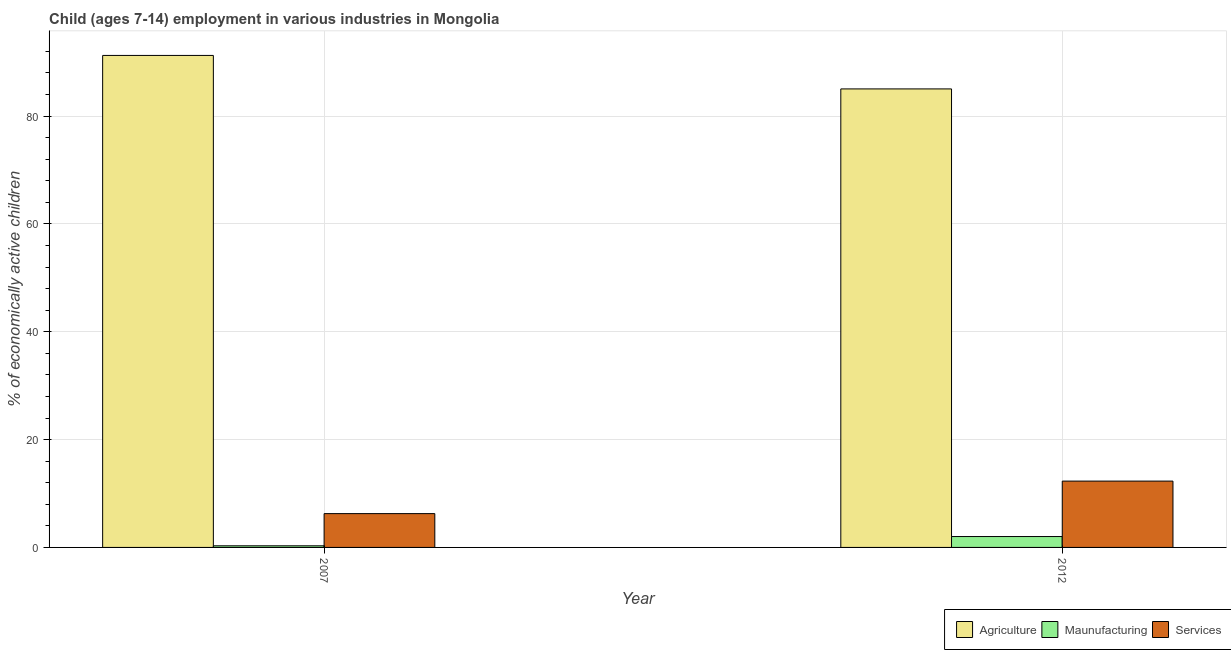How many different coloured bars are there?
Give a very brief answer. 3. Are the number of bars per tick equal to the number of legend labels?
Your answer should be compact. Yes. How many bars are there on the 1st tick from the left?
Provide a succinct answer. 3. How many bars are there on the 2nd tick from the right?
Offer a very short reply. 3. Across all years, what is the maximum percentage of economically active children in agriculture?
Keep it short and to the point. 91.25. Across all years, what is the minimum percentage of economically active children in agriculture?
Your answer should be very brief. 85.04. In which year was the percentage of economically active children in services maximum?
Keep it short and to the point. 2012. What is the total percentage of economically active children in agriculture in the graph?
Offer a terse response. 176.29. What is the difference between the percentage of economically active children in agriculture in 2007 and that in 2012?
Provide a short and direct response. 6.21. What is the difference between the percentage of economically active children in services in 2007 and the percentage of economically active children in manufacturing in 2012?
Your answer should be very brief. -6.03. What is the average percentage of economically active children in agriculture per year?
Offer a terse response. 88.15. In the year 2007, what is the difference between the percentage of economically active children in services and percentage of economically active children in agriculture?
Provide a short and direct response. 0. In how many years, is the percentage of economically active children in manufacturing greater than 72 %?
Your answer should be very brief. 0. What is the ratio of the percentage of economically active children in services in 2007 to that in 2012?
Your response must be concise. 0.51. What does the 2nd bar from the left in 2012 represents?
Your response must be concise. Maunufacturing. What does the 3rd bar from the right in 2007 represents?
Provide a short and direct response. Agriculture. Is it the case that in every year, the sum of the percentage of economically active children in agriculture and percentage of economically active children in manufacturing is greater than the percentage of economically active children in services?
Make the answer very short. Yes. How many bars are there?
Offer a very short reply. 6. Are all the bars in the graph horizontal?
Your response must be concise. No. How many years are there in the graph?
Your answer should be very brief. 2. Are the values on the major ticks of Y-axis written in scientific E-notation?
Provide a short and direct response. No. Does the graph contain any zero values?
Give a very brief answer. No. Does the graph contain grids?
Keep it short and to the point. Yes. How many legend labels are there?
Make the answer very short. 3. What is the title of the graph?
Your answer should be compact. Child (ages 7-14) employment in various industries in Mongolia. Does "Domestic economy" appear as one of the legend labels in the graph?
Ensure brevity in your answer.  No. What is the label or title of the Y-axis?
Offer a very short reply. % of economically active children. What is the % of economically active children in Agriculture in 2007?
Offer a terse response. 91.25. What is the % of economically active children of Maunufacturing in 2007?
Provide a short and direct response. 0.3. What is the % of economically active children in Services in 2007?
Provide a succinct answer. 6.27. What is the % of economically active children in Agriculture in 2012?
Make the answer very short. 85.04. What is the % of economically active children of Maunufacturing in 2012?
Keep it short and to the point. 2.02. What is the % of economically active children of Services in 2012?
Offer a terse response. 12.3. Across all years, what is the maximum % of economically active children in Agriculture?
Give a very brief answer. 91.25. Across all years, what is the maximum % of economically active children of Maunufacturing?
Keep it short and to the point. 2.02. Across all years, what is the maximum % of economically active children of Services?
Your answer should be very brief. 12.3. Across all years, what is the minimum % of economically active children of Agriculture?
Make the answer very short. 85.04. Across all years, what is the minimum % of economically active children of Services?
Offer a terse response. 6.27. What is the total % of economically active children in Agriculture in the graph?
Offer a terse response. 176.29. What is the total % of economically active children in Maunufacturing in the graph?
Keep it short and to the point. 2.32. What is the total % of economically active children in Services in the graph?
Provide a succinct answer. 18.57. What is the difference between the % of economically active children of Agriculture in 2007 and that in 2012?
Keep it short and to the point. 6.21. What is the difference between the % of economically active children of Maunufacturing in 2007 and that in 2012?
Give a very brief answer. -1.72. What is the difference between the % of economically active children in Services in 2007 and that in 2012?
Provide a short and direct response. -6.03. What is the difference between the % of economically active children of Agriculture in 2007 and the % of economically active children of Maunufacturing in 2012?
Your answer should be compact. 89.23. What is the difference between the % of economically active children of Agriculture in 2007 and the % of economically active children of Services in 2012?
Your answer should be compact. 78.95. What is the difference between the % of economically active children of Maunufacturing in 2007 and the % of economically active children of Services in 2012?
Offer a very short reply. -12. What is the average % of economically active children of Agriculture per year?
Make the answer very short. 88.14. What is the average % of economically active children of Maunufacturing per year?
Your answer should be very brief. 1.16. What is the average % of economically active children of Services per year?
Ensure brevity in your answer.  9.29. In the year 2007, what is the difference between the % of economically active children in Agriculture and % of economically active children in Maunufacturing?
Give a very brief answer. 90.95. In the year 2007, what is the difference between the % of economically active children of Agriculture and % of economically active children of Services?
Ensure brevity in your answer.  84.98. In the year 2007, what is the difference between the % of economically active children in Maunufacturing and % of economically active children in Services?
Keep it short and to the point. -5.97. In the year 2012, what is the difference between the % of economically active children in Agriculture and % of economically active children in Maunufacturing?
Ensure brevity in your answer.  83.02. In the year 2012, what is the difference between the % of economically active children of Agriculture and % of economically active children of Services?
Offer a terse response. 72.74. In the year 2012, what is the difference between the % of economically active children of Maunufacturing and % of economically active children of Services?
Your response must be concise. -10.28. What is the ratio of the % of economically active children in Agriculture in 2007 to that in 2012?
Give a very brief answer. 1.07. What is the ratio of the % of economically active children of Maunufacturing in 2007 to that in 2012?
Your answer should be compact. 0.15. What is the ratio of the % of economically active children in Services in 2007 to that in 2012?
Ensure brevity in your answer.  0.51. What is the difference between the highest and the second highest % of economically active children in Agriculture?
Give a very brief answer. 6.21. What is the difference between the highest and the second highest % of economically active children in Maunufacturing?
Make the answer very short. 1.72. What is the difference between the highest and the second highest % of economically active children in Services?
Offer a terse response. 6.03. What is the difference between the highest and the lowest % of economically active children in Agriculture?
Keep it short and to the point. 6.21. What is the difference between the highest and the lowest % of economically active children in Maunufacturing?
Provide a short and direct response. 1.72. What is the difference between the highest and the lowest % of economically active children of Services?
Your answer should be very brief. 6.03. 